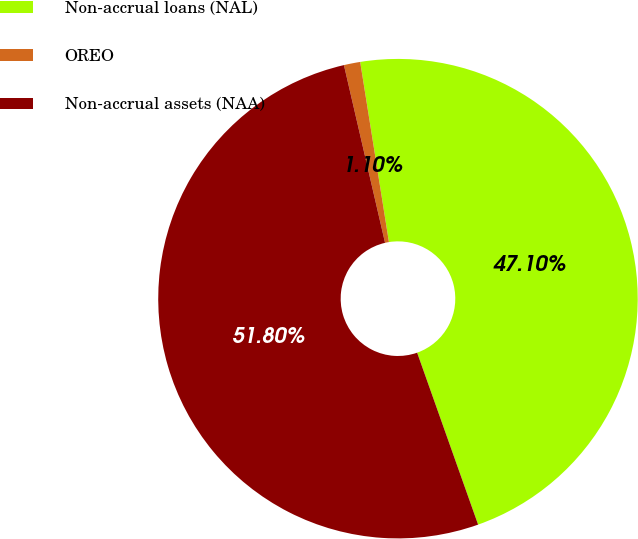<chart> <loc_0><loc_0><loc_500><loc_500><pie_chart><fcel>Non-accrual loans (NAL)<fcel>OREO<fcel>Non-accrual assets (NAA)<nl><fcel>47.1%<fcel>1.1%<fcel>51.81%<nl></chart> 